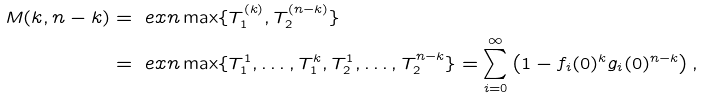Convert formula to latex. <formula><loc_0><loc_0><loc_500><loc_500>M ( k , n - k ) & = \ e x n \max \{ T _ { 1 } ^ { ( k ) } , T _ { 2 } ^ { ( n - k ) } \} \\ & = \ e x n \max \{ T _ { 1 } ^ { 1 } , \dots , T _ { 1 } ^ { k } , T _ { 2 } ^ { 1 } , \dots , T _ { 2 } ^ { n - k } \} = \sum _ { i = 0 } ^ { \infty } \left ( 1 - f _ { i } ( 0 ) ^ { k } g _ { i } ( 0 ) ^ { n - k } \right ) ,</formula> 